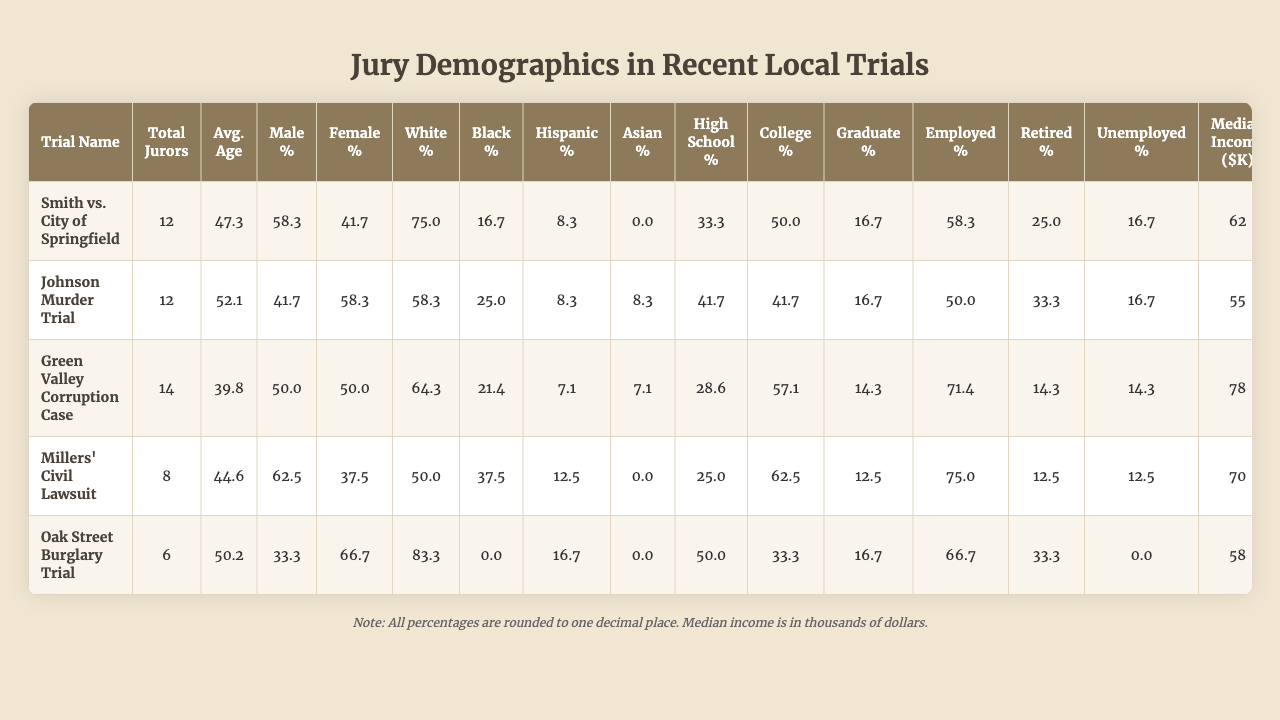What is the trial with the highest percentage of male jurors? Looking at the table, "Millers' Civil Lawsuit" has the highest male percentage at 62.5%.
Answer: Millers' Civil Lawsuit Which trial has the lowest average age of jurors? The "Green Valley Corruption Case" has the lowest average age at 39.8 years.
Answer: Green Valley Corruption Case How many jurors were retired in the Johnson Murder Trial? 33.3% of 12 jurors means approximately 4 jurors were retired in the Johnson Murder Trial (0.333 x 12 = 4).
Answer: 4 What is the median income of jurors in the Green Valley Corruption Case? The median income listed for jurors in the Green Valley Corruption Case is $78,000.
Answer: $78,000 Is the percentage of unemployed jurors higher in the Oak Street Burglary Trial than in the Millers' Civil Lawsuit? The Oak Street Burglary Trial has 0% unemployed jurors, while the Millers' Civil Lawsuit has 12.5%. Therefore, it is false that Oak Street has a higher percentage.
Answer: No What is the difference in the percentage of female jurors between the Johnson Murder Trial and the Oak Street Burglary Trial? The Johnson Murder Trial has 58.3% female jurors, while the Oak Street Burglary Trial has 66.7%. The difference is 66.7% - 58.3% = 8.4%.
Answer: 8.4% Which trial has a higher percentage of jurors with a college education, the Millers' Civil Lawsuit or the Johnson Murder Trial? The Millers' Civil Lawsuit has 62.5% college-educated jurors and the Johnson Murder Trial has 41.7%. Thus, Millers' Civil Lawsuit has a higher percentage.
Answer: Millers' Civil Lawsuit What is the average percentage of white jurors across all trials? Adding the percentages of white jurors (75.0 + 58.3 + 64.3 + 50.0 + 83.3 = 330.9) and dividing by 5 gives an average of approximately 66.18%.
Answer: 66.18% Is the trial with the highest total jurors also the one with the highest percentage of employed jurors? The trial with the highest total jurors is "Smith vs. City of Springfield" with 12 total jurors and an employed percentage of 58.3%. The trial with the highest employed percentage is "Millers' Civil Lawsuit" at 75.0%, which has fewer jurors. Thus, the statement is false.
Answer: No How many total jurors across all trials are either employed or retired? To find this, we calculate the total percentages of employed (58.3 + 50.0 + 71.4 + 75.0 + 66.7) and retired jurors (25.0 + 33.3 + 14.3 + 12.5 + 33.3) for each trial, giving us 71.7 total employed and 32.9 total retired. Thus, total jurors = sum of (total jurors from each trial) = 52, out of which employed and retired jurors combined would be calculated separately.
Answer: 52 